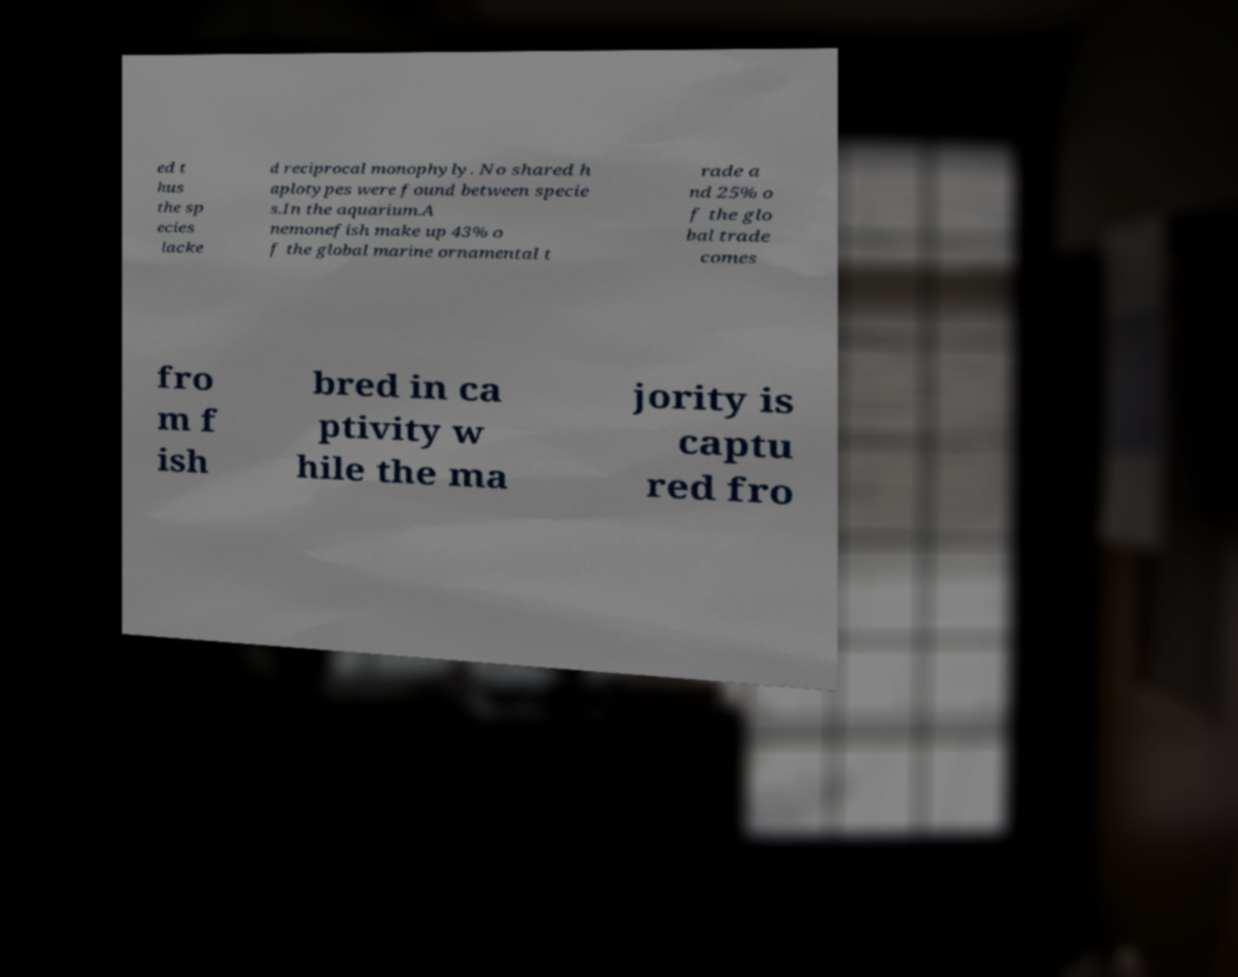Could you extract and type out the text from this image? ed t hus the sp ecies lacke d reciprocal monophyly. No shared h aplotypes were found between specie s.In the aquarium.A nemonefish make up 43% o f the global marine ornamental t rade a nd 25% o f the glo bal trade comes fro m f ish bred in ca ptivity w hile the ma jority is captu red fro 